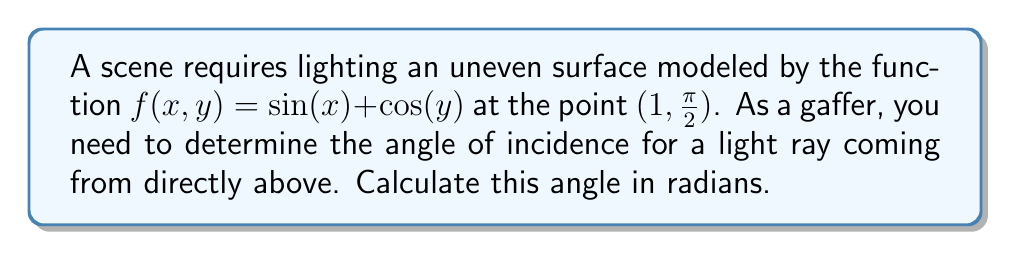Could you help me with this problem? To solve this problem, we'll follow these steps:

1) The angle of incidence is the angle between the incoming light ray and the normal vector to the surface at the given point.

2) For a surface $z = f(x,y)$, the normal vector at any point is given by:

   $$\vec{N} = \left(-\frac{\partial f}{\partial x}, -\frac{\partial f}{\partial y}, 1\right)$$

3) Let's calculate the partial derivatives:
   
   $\frac{\partial f}{\partial x} = \cos(x)$
   $\frac{\partial f}{\partial y} = -\sin(y)$

4) At the point $(1, \frac{\pi}{2})$:
   
   $\frac{\partial f}{\partial x} = \cos(1)$
   $\frac{\partial f}{\partial y} = -\sin(\frac{\pi}{2}) = -1$

5) So, the normal vector at this point is:

   $$\vec{N} = (-\cos(1), 1, 1)$$

6) The light ray coming from directly above is represented by the vector:

   $$\vec{L} = (0, 0, -1)$$

7) The angle $\theta$ between these vectors is given by:

   $$\cos(\theta) = \frac{\vec{N} \cdot \vec{L}}{|\vec{N}||\vec{L}|}$$

8) Calculating the dot product and magnitudes:

   $$\vec{N} \cdot \vec{L} = -1$$
   $$|\vec{N}| = \sqrt{\cos^2(1) + 1^2 + 1^2} = \sqrt{\cos^2(1) + 2}$$
   $$|\vec{L}| = 1$$

9) Substituting into the formula:

   $$\cos(\theta) = \frac{-1}{\sqrt{\cos^2(1) + 2}}$$

10) The angle of incidence is therefore:

    $$\theta = \arccos\left(\frac{-1}{\sqrt{\cos^2(1) + 2}}\right)$$
Answer: $\arccos\left(\frac{-1}{\sqrt{\cos^2(1) + 2}}\right)$ radians 